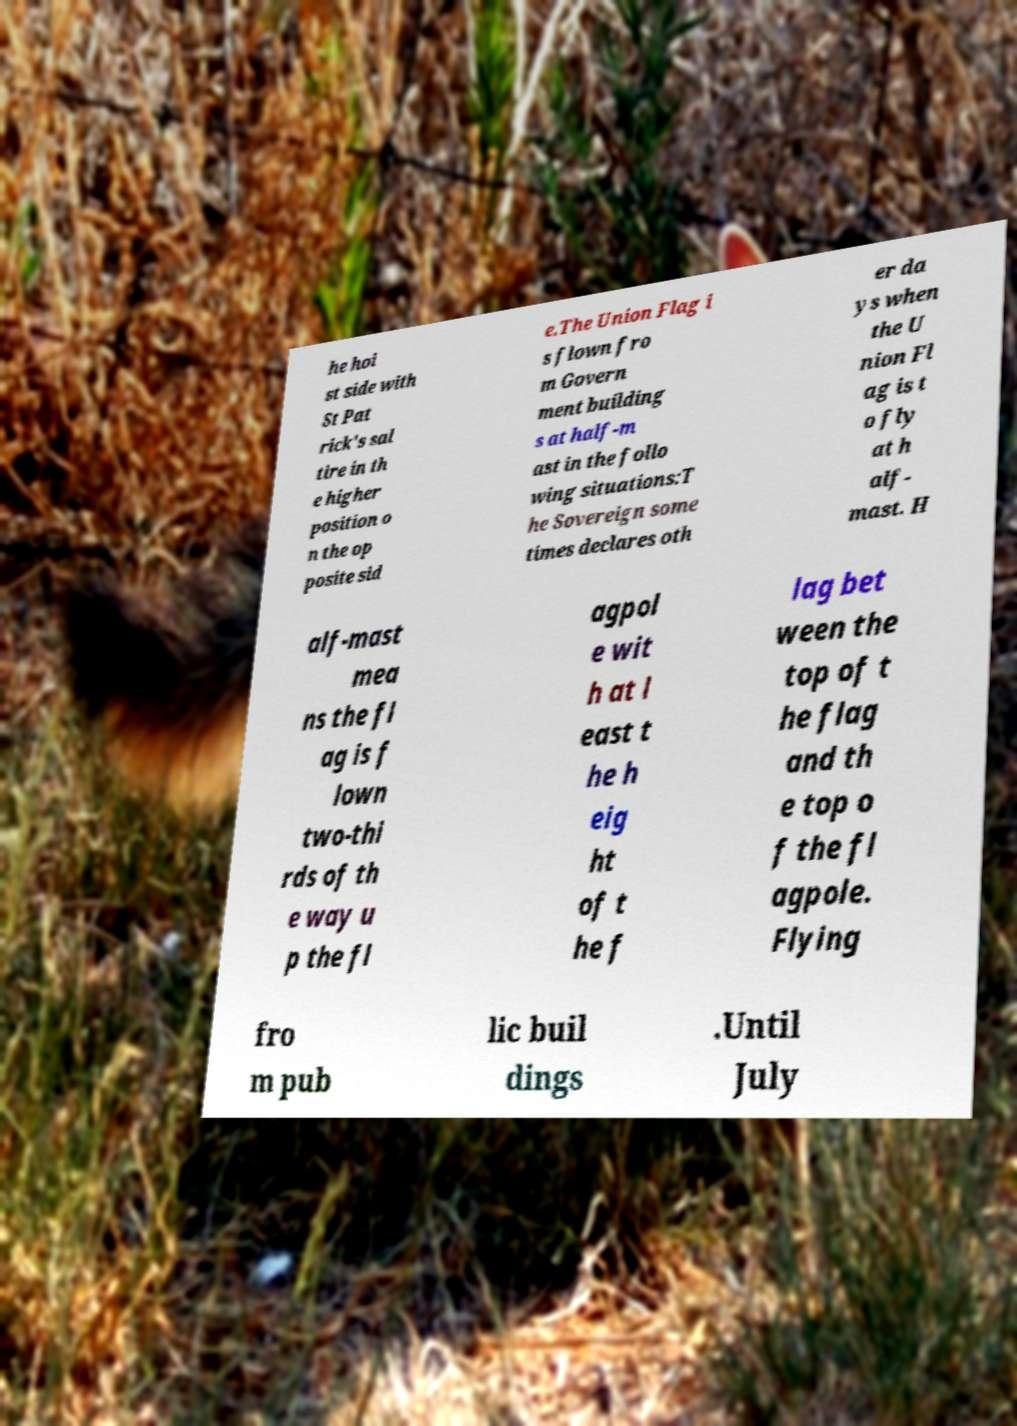Please identify and transcribe the text found in this image. he hoi st side with St Pat rick's sal tire in th e higher position o n the op posite sid e.The Union Flag i s flown fro m Govern ment building s at half-m ast in the follo wing situations:T he Sovereign some times declares oth er da ys when the U nion Fl ag is t o fly at h alf- mast. H alf-mast mea ns the fl ag is f lown two-thi rds of th e way u p the fl agpol e wit h at l east t he h eig ht of t he f lag bet ween the top of t he flag and th e top o f the fl agpole. Flying fro m pub lic buil dings .Until July 